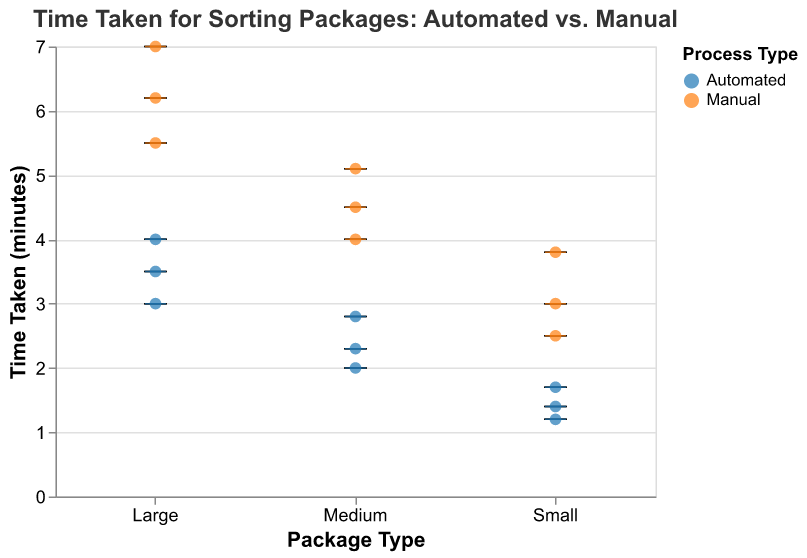What is the title of the figure? The title of the figure is displayed prominently at the top.
Answer: Time Taken for Sorting Packages: Automated vs. Manual What are the different process types compared in the figure? The legend shows two colors representing two process types.
Answer: Automated and Manual How is the weather condition represented in the figure? Weather conditions are represented in separate columns in the plot.
Answer: As different columns What is the median time taken for sorting small packages manually in snowy weather? Look at the 'Small' package type in the 'Snowy' weather column, then check the median line in the box for the 'Manual' process type.
Answer: 3.8 minutes How does the time taken for automated sorting compare to manual sorting for large packages in rainy weather? Compare the heights of the boxes for 'Automated' and 'Manual' processes under 'Large' package type in 'Rainy' weather.
Answer: Automated sorting takes less time than manual sorting (3.5 minutes vs. 6.2 minutes) Which weather condition shows the largest difference between automated and manual sorting times for medium packages? Compare the differences (spread) between automated and manual sorting times in each weather condition for medium packages.
Answer: Snowy (2.3 minutes vs. 5.1 minutes) On average, which process type is faster for sorting packages, automated or manual? Examine the boxes for both process types across all packages and weather conditions; automated seems consistently lower.
Answer: Automated For large packages, in which weather condition is the automated sorting time the highest? Compare the height of the 'Automated' boxes for 'Large' packages under the three weather conditions.
Answer: Snowy Describe the trend in time taken for sorting medium packages manually when comparing sunny, rainy, and snowy conditions. Observe the 'Manual' boxes for 'Medium' packages across 'Sunny,' 'Rainy,' and 'Snowy' weather conditions.
Answer: Time taken increases from sunny (4.0) to rainy (4.5) to snowy (5.1) What can you infer about the impact of weather conditions on manual sorting times as compared to automated sorting times? Compare the spread of manual and automated sorting times across all weather conditions; manual times show a larger increase.
Answer: Weather has a greater impact on manual sorting times than automated 